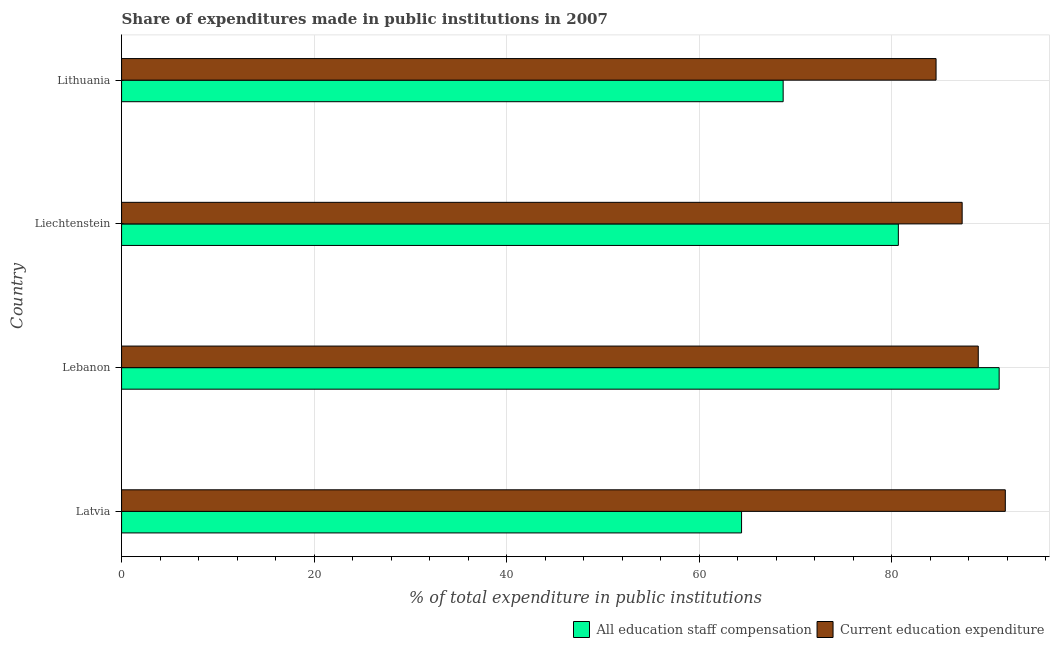Are the number of bars per tick equal to the number of legend labels?
Ensure brevity in your answer.  Yes. Are the number of bars on each tick of the Y-axis equal?
Keep it short and to the point. Yes. How many bars are there on the 4th tick from the bottom?
Make the answer very short. 2. What is the label of the 1st group of bars from the top?
Your answer should be very brief. Lithuania. What is the expenditure in education in Lithuania?
Keep it short and to the point. 84.61. Across all countries, what is the maximum expenditure in education?
Give a very brief answer. 91.8. Across all countries, what is the minimum expenditure in education?
Your response must be concise. 84.61. In which country was the expenditure in education maximum?
Your answer should be compact. Latvia. In which country was the expenditure in education minimum?
Offer a very short reply. Lithuania. What is the total expenditure in staff compensation in the graph?
Give a very brief answer. 304.98. What is the difference between the expenditure in education in Liechtenstein and that in Lithuania?
Give a very brief answer. 2.71. What is the difference between the expenditure in education in Latvia and the expenditure in staff compensation in Lebanon?
Your response must be concise. 0.64. What is the average expenditure in staff compensation per country?
Offer a very short reply. 76.25. What is the difference between the expenditure in staff compensation and expenditure in education in Liechtenstein?
Offer a terse response. -6.63. In how many countries, is the expenditure in staff compensation greater than 84 %?
Offer a very short reply. 1. What is the ratio of the expenditure in staff compensation in Liechtenstein to that in Lithuania?
Ensure brevity in your answer.  1.17. What is the difference between the highest and the second highest expenditure in education?
Your answer should be very brief. 2.81. What is the difference between the highest and the lowest expenditure in education?
Make the answer very short. 7.19. Is the sum of the expenditure in staff compensation in Latvia and Lebanon greater than the maximum expenditure in education across all countries?
Offer a terse response. Yes. What does the 2nd bar from the top in Lebanon represents?
Make the answer very short. All education staff compensation. What does the 2nd bar from the bottom in Lithuania represents?
Keep it short and to the point. Current education expenditure. How many bars are there?
Provide a succinct answer. 8. Are all the bars in the graph horizontal?
Ensure brevity in your answer.  Yes. Does the graph contain grids?
Offer a very short reply. Yes. Where does the legend appear in the graph?
Give a very brief answer. Bottom right. What is the title of the graph?
Your answer should be very brief. Share of expenditures made in public institutions in 2007. What is the label or title of the X-axis?
Give a very brief answer. % of total expenditure in public institutions. What is the label or title of the Y-axis?
Provide a succinct answer. Country. What is the % of total expenditure in public institutions in All education staff compensation in Latvia?
Keep it short and to the point. 64.4. What is the % of total expenditure in public institutions of Current education expenditure in Latvia?
Keep it short and to the point. 91.8. What is the % of total expenditure in public institutions of All education staff compensation in Lebanon?
Your response must be concise. 91.16. What is the % of total expenditure in public institutions of Current education expenditure in Lebanon?
Provide a short and direct response. 88.99. What is the % of total expenditure in public institutions in All education staff compensation in Liechtenstein?
Offer a terse response. 80.69. What is the % of total expenditure in public institutions of Current education expenditure in Liechtenstein?
Make the answer very short. 87.32. What is the % of total expenditure in public institutions in All education staff compensation in Lithuania?
Your answer should be very brief. 68.72. What is the % of total expenditure in public institutions of Current education expenditure in Lithuania?
Make the answer very short. 84.61. Across all countries, what is the maximum % of total expenditure in public institutions in All education staff compensation?
Your answer should be very brief. 91.16. Across all countries, what is the maximum % of total expenditure in public institutions in Current education expenditure?
Ensure brevity in your answer.  91.8. Across all countries, what is the minimum % of total expenditure in public institutions of All education staff compensation?
Provide a short and direct response. 64.4. Across all countries, what is the minimum % of total expenditure in public institutions in Current education expenditure?
Your response must be concise. 84.61. What is the total % of total expenditure in public institutions in All education staff compensation in the graph?
Offer a terse response. 304.98. What is the total % of total expenditure in public institutions of Current education expenditure in the graph?
Provide a succinct answer. 352.72. What is the difference between the % of total expenditure in public institutions of All education staff compensation in Latvia and that in Lebanon?
Ensure brevity in your answer.  -26.76. What is the difference between the % of total expenditure in public institutions of Current education expenditure in Latvia and that in Lebanon?
Keep it short and to the point. 2.81. What is the difference between the % of total expenditure in public institutions in All education staff compensation in Latvia and that in Liechtenstein?
Keep it short and to the point. -16.29. What is the difference between the % of total expenditure in public institutions in Current education expenditure in Latvia and that in Liechtenstein?
Your answer should be very brief. 4.48. What is the difference between the % of total expenditure in public institutions in All education staff compensation in Latvia and that in Lithuania?
Offer a very short reply. -4.32. What is the difference between the % of total expenditure in public institutions in Current education expenditure in Latvia and that in Lithuania?
Offer a very short reply. 7.19. What is the difference between the % of total expenditure in public institutions of All education staff compensation in Lebanon and that in Liechtenstein?
Offer a very short reply. 10.47. What is the difference between the % of total expenditure in public institutions in Current education expenditure in Lebanon and that in Liechtenstein?
Give a very brief answer. 1.67. What is the difference between the % of total expenditure in public institutions of All education staff compensation in Lebanon and that in Lithuania?
Offer a very short reply. 22.44. What is the difference between the % of total expenditure in public institutions in Current education expenditure in Lebanon and that in Lithuania?
Offer a very short reply. 4.38. What is the difference between the % of total expenditure in public institutions of All education staff compensation in Liechtenstein and that in Lithuania?
Offer a terse response. 11.97. What is the difference between the % of total expenditure in public institutions of Current education expenditure in Liechtenstein and that in Lithuania?
Give a very brief answer. 2.71. What is the difference between the % of total expenditure in public institutions in All education staff compensation in Latvia and the % of total expenditure in public institutions in Current education expenditure in Lebanon?
Give a very brief answer. -24.59. What is the difference between the % of total expenditure in public institutions of All education staff compensation in Latvia and the % of total expenditure in public institutions of Current education expenditure in Liechtenstein?
Your answer should be very brief. -22.91. What is the difference between the % of total expenditure in public institutions of All education staff compensation in Latvia and the % of total expenditure in public institutions of Current education expenditure in Lithuania?
Offer a very short reply. -20.21. What is the difference between the % of total expenditure in public institutions in All education staff compensation in Lebanon and the % of total expenditure in public institutions in Current education expenditure in Liechtenstein?
Your answer should be very brief. 3.84. What is the difference between the % of total expenditure in public institutions in All education staff compensation in Lebanon and the % of total expenditure in public institutions in Current education expenditure in Lithuania?
Your response must be concise. 6.55. What is the difference between the % of total expenditure in public institutions in All education staff compensation in Liechtenstein and the % of total expenditure in public institutions in Current education expenditure in Lithuania?
Make the answer very short. -3.92. What is the average % of total expenditure in public institutions of All education staff compensation per country?
Provide a short and direct response. 76.25. What is the average % of total expenditure in public institutions in Current education expenditure per country?
Ensure brevity in your answer.  88.18. What is the difference between the % of total expenditure in public institutions in All education staff compensation and % of total expenditure in public institutions in Current education expenditure in Latvia?
Give a very brief answer. -27.4. What is the difference between the % of total expenditure in public institutions of All education staff compensation and % of total expenditure in public institutions of Current education expenditure in Lebanon?
Offer a terse response. 2.17. What is the difference between the % of total expenditure in public institutions in All education staff compensation and % of total expenditure in public institutions in Current education expenditure in Liechtenstein?
Provide a succinct answer. -6.63. What is the difference between the % of total expenditure in public institutions in All education staff compensation and % of total expenditure in public institutions in Current education expenditure in Lithuania?
Offer a terse response. -15.88. What is the ratio of the % of total expenditure in public institutions of All education staff compensation in Latvia to that in Lebanon?
Provide a short and direct response. 0.71. What is the ratio of the % of total expenditure in public institutions of Current education expenditure in Latvia to that in Lebanon?
Your response must be concise. 1.03. What is the ratio of the % of total expenditure in public institutions of All education staff compensation in Latvia to that in Liechtenstein?
Your answer should be compact. 0.8. What is the ratio of the % of total expenditure in public institutions of Current education expenditure in Latvia to that in Liechtenstein?
Provide a short and direct response. 1.05. What is the ratio of the % of total expenditure in public institutions of All education staff compensation in Latvia to that in Lithuania?
Provide a short and direct response. 0.94. What is the ratio of the % of total expenditure in public institutions in Current education expenditure in Latvia to that in Lithuania?
Make the answer very short. 1.08. What is the ratio of the % of total expenditure in public institutions of All education staff compensation in Lebanon to that in Liechtenstein?
Offer a very short reply. 1.13. What is the ratio of the % of total expenditure in public institutions of Current education expenditure in Lebanon to that in Liechtenstein?
Your answer should be compact. 1.02. What is the ratio of the % of total expenditure in public institutions in All education staff compensation in Lebanon to that in Lithuania?
Keep it short and to the point. 1.33. What is the ratio of the % of total expenditure in public institutions in Current education expenditure in Lebanon to that in Lithuania?
Provide a short and direct response. 1.05. What is the ratio of the % of total expenditure in public institutions of All education staff compensation in Liechtenstein to that in Lithuania?
Offer a terse response. 1.17. What is the ratio of the % of total expenditure in public institutions in Current education expenditure in Liechtenstein to that in Lithuania?
Provide a short and direct response. 1.03. What is the difference between the highest and the second highest % of total expenditure in public institutions of All education staff compensation?
Your response must be concise. 10.47. What is the difference between the highest and the second highest % of total expenditure in public institutions in Current education expenditure?
Give a very brief answer. 2.81. What is the difference between the highest and the lowest % of total expenditure in public institutions of All education staff compensation?
Give a very brief answer. 26.76. What is the difference between the highest and the lowest % of total expenditure in public institutions in Current education expenditure?
Make the answer very short. 7.19. 